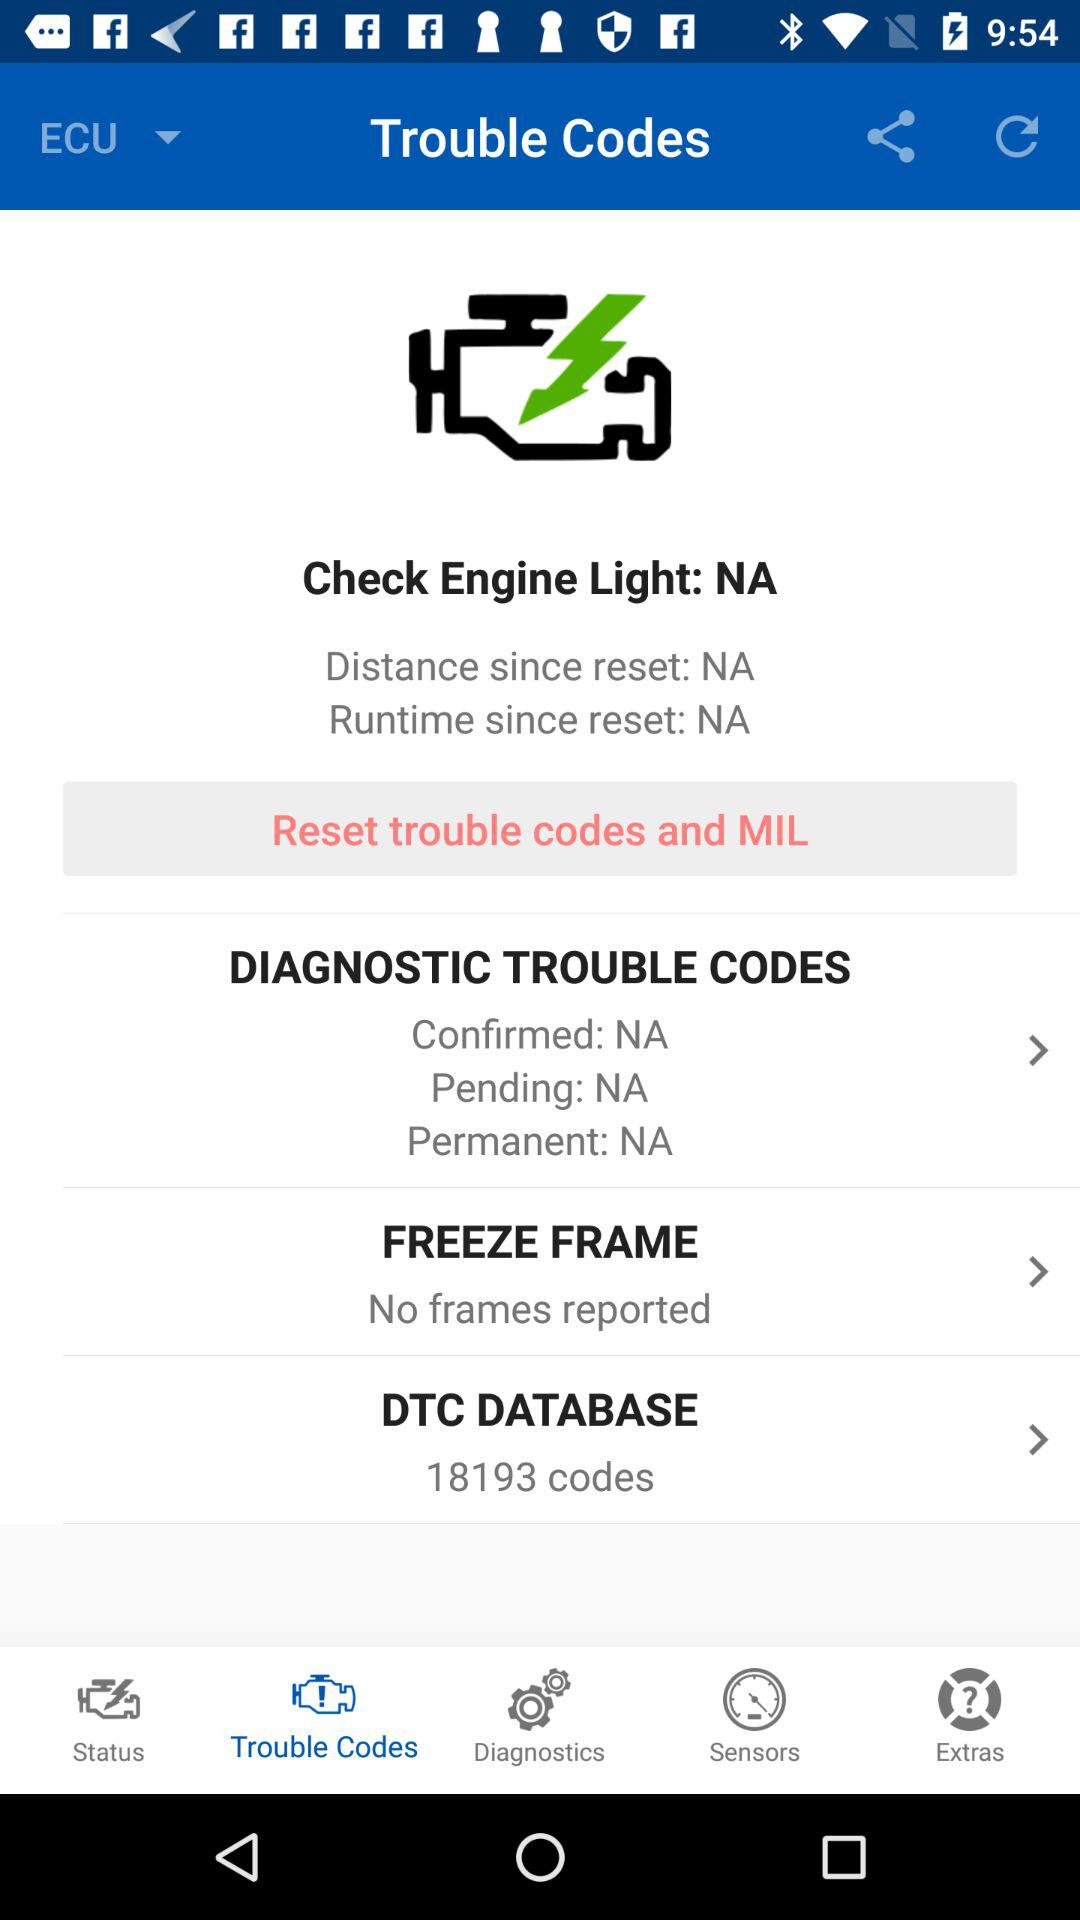What is the "Distance since reset"? The "Distance since reset" is "NA". 